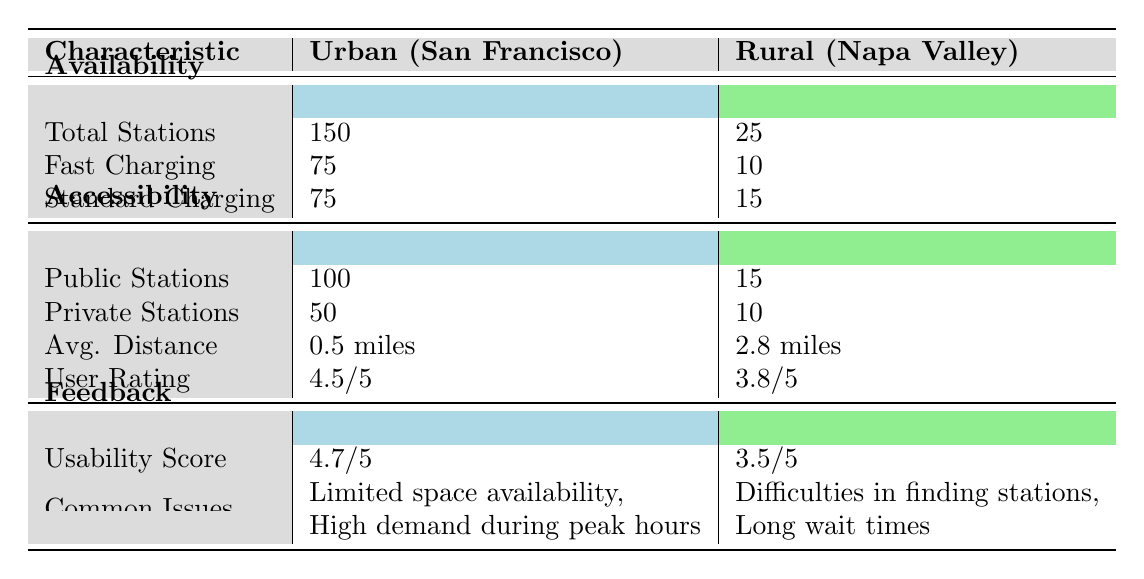What is the total number of charging stations in urban areas? The total number of charging stations in urban areas, specifically San Francisco, is listed under the "Total Stations" row in the Availability section. According to the table, this value is 150.
Answer: 150 How many more fast charging stations are there in urban areas compared to rural areas? To find the difference in fast charging stations, we look at the Fast Charging row under Availability. Urban has 75 stations while rural has 10 stations. The difference is calculated as 75 - 10 = 65.
Answer: 65 Is the user rating for charging stations higher in urban areas than in rural areas? The user ratings are provided in the Accessibility section. Urban has a user rating of 4.5 out of 5, while rural has a rating of 3.8 out of 5. Since 4.5 is greater than 3.8, the answer is yes.
Answer: Yes What is the average distance to charging stations in urban areas compared to rural areas? The average distance to stations is noted in the Accessibility section. Urban areas report an average distance of 0.5 miles, whereas rural areas report 2.8 miles. Thus, the average distance to charging stations is lower in urban areas.
Answer: 0.5 miles (urban), 2.8 miles (rural) How many more private charging stations are available in urban areas compared to rural areas? The number of private stations can be found in the Accessibility section. Urban has 50 private stations, while rural has 10. The difference is 50 - 10 = 40.
Answer: 40 What common issue is reported in urban areas that is not mentioned for rural areas? The common issues for each area are listed under the Feedback section. Urban areas specifically mention "High demand during peak hours" amongst their common issues; rural areas do not mention this.
Answer: High demand during peak hours Do rural charging stations have a higher usability score than urban stations? The usability scores are indicated in the Feedback section. Urban has a usability score of 4.7, while rural has 3.5. Since 4.7 is greater than 3.5, the answer is no.
Answer: No What is the total number of public and private charging stations in rural areas? We sum the values for public and private stations in the Accessibility section for rural areas: 15 (public) + 10 (private) = 25.
Answer: 25 Which area has more charging stations overall, and by how much? The total number of stations in urban areas is 150 and in rural areas is 25. The difference is 150 - 25 = 125. Urban areas have more stations by 125.
Answer: Urban areas by 125 